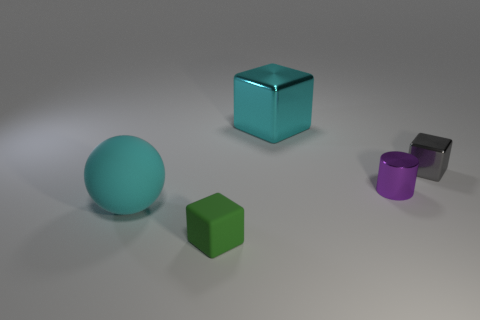Can you describe the colors of the objects in the image? Certainly! The image includes a large cyan cube, a small green cube, a large teal sphere, a small purple cylinder, and a small grey cube. 